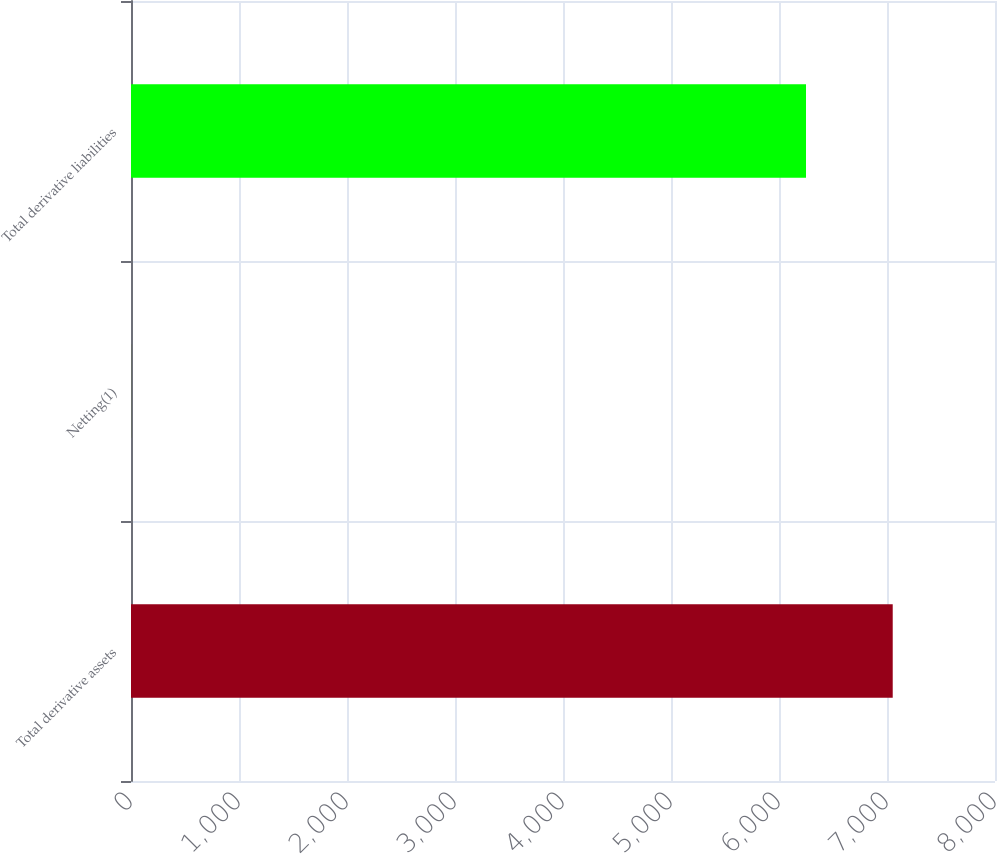Convert chart to OTSL. <chart><loc_0><loc_0><loc_500><loc_500><bar_chart><fcel>Total derivative assets<fcel>Netting(1)<fcel>Total derivative liabilities<nl><fcel>7053<fcel>1.67<fcel>6250<nl></chart> 